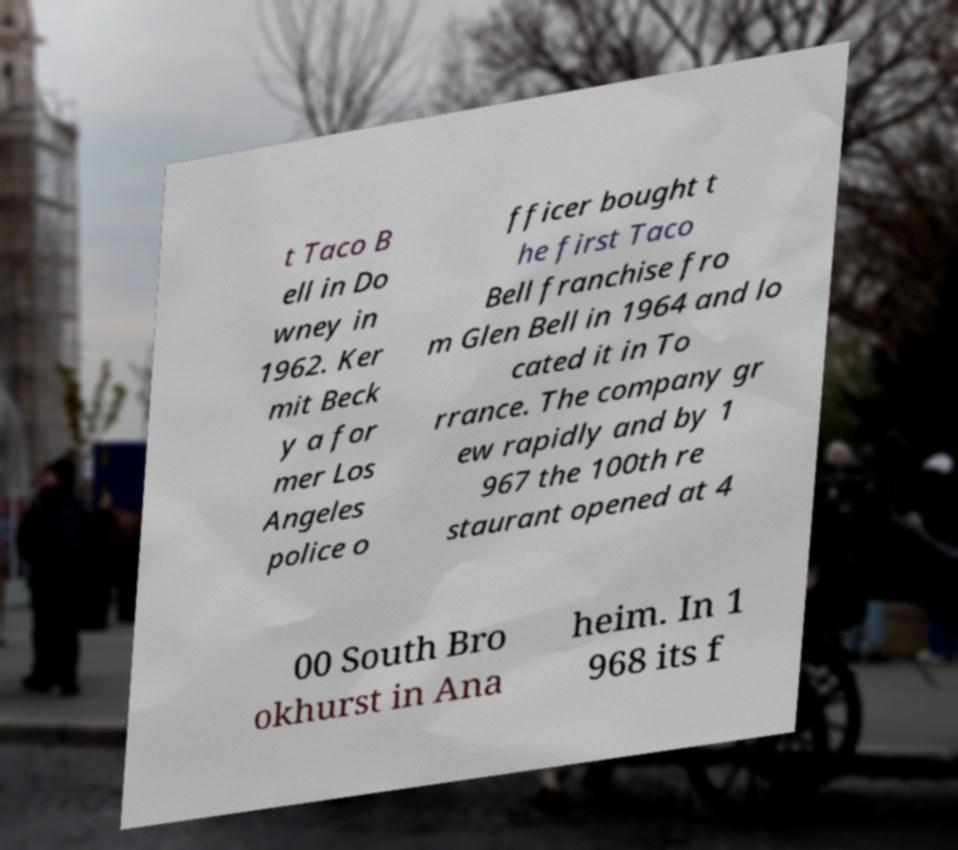For documentation purposes, I need the text within this image transcribed. Could you provide that? t Taco B ell in Do wney in 1962. Ker mit Beck y a for mer Los Angeles police o fficer bought t he first Taco Bell franchise fro m Glen Bell in 1964 and lo cated it in To rrance. The company gr ew rapidly and by 1 967 the 100th re staurant opened at 4 00 South Bro okhurst in Ana heim. In 1 968 its f 